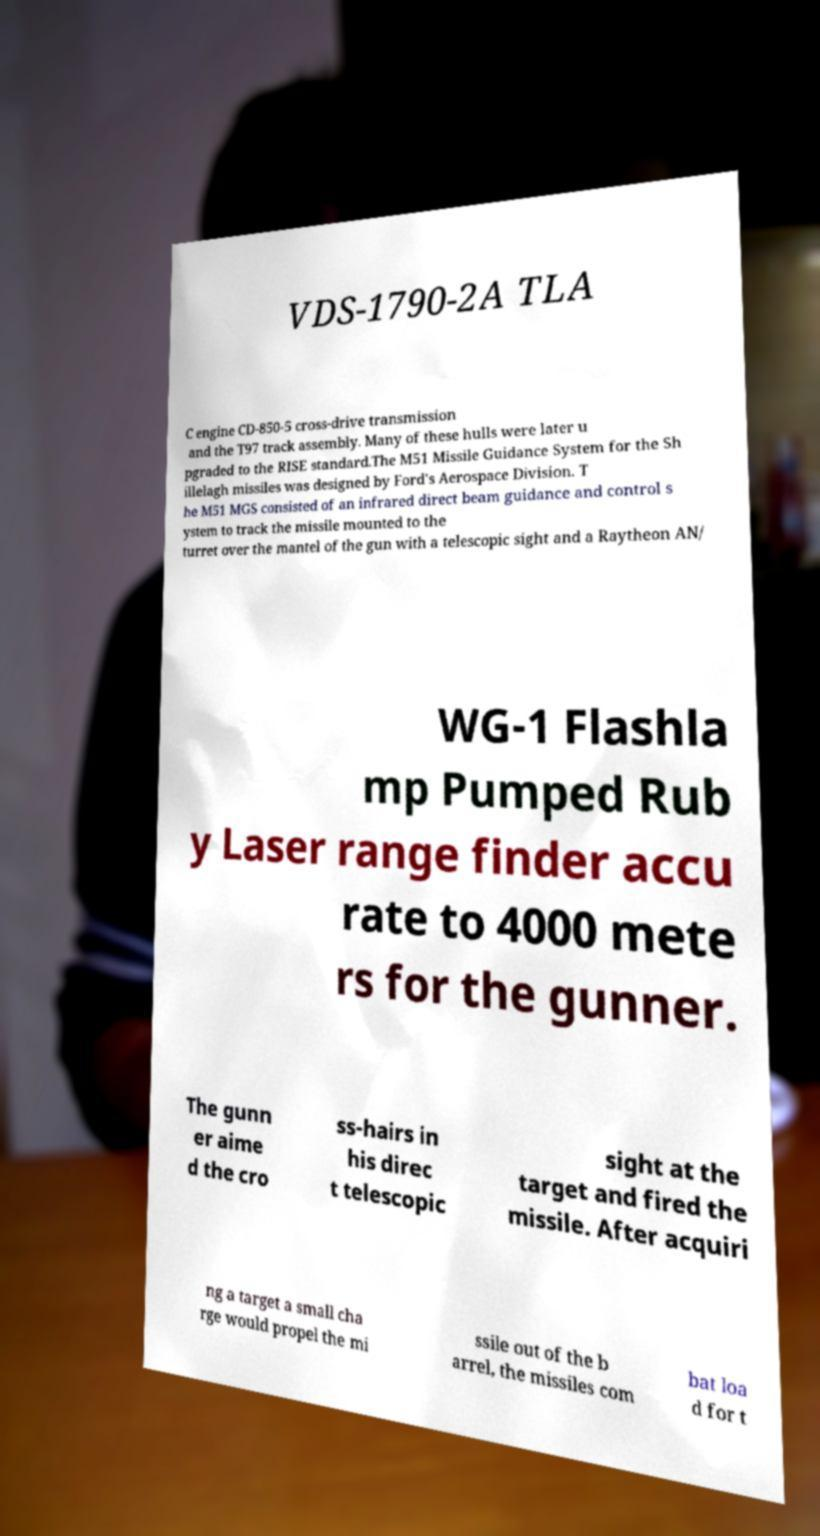I need the written content from this picture converted into text. Can you do that? VDS-1790-2A TLA C engine CD-850-5 cross-drive transmission and the T97 track assembly. Many of these hulls were later u pgraded to the RISE standard.The M51 Missile Guidance System for the Sh illelagh missiles was designed by Ford's Aerospace Division. T he M51 MGS consisted of an infrared direct beam guidance and control s ystem to track the missile mounted to the turret over the mantel of the gun with a telescopic sight and a Raytheon AN/ WG-1 Flashla mp Pumped Rub y Laser range finder accu rate to 4000 mete rs for the gunner. The gunn er aime d the cro ss-hairs in his direc t telescopic sight at the target and fired the missile. After acquiri ng a target a small cha rge would propel the mi ssile out of the b arrel, the missiles com bat loa d for t 